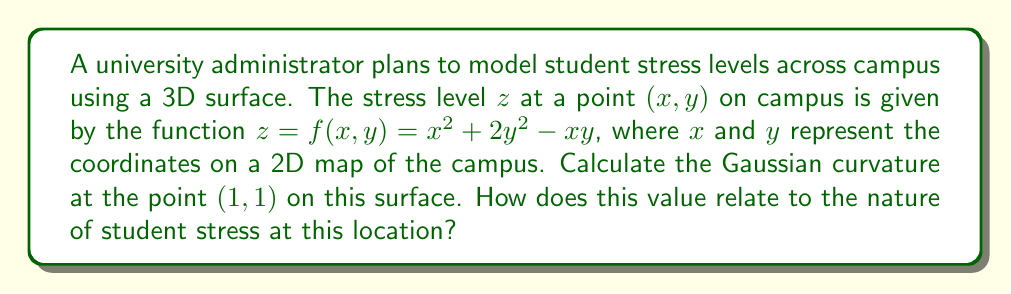Teach me how to tackle this problem. To find the Gaussian curvature, we need to follow these steps:

1) The Gaussian curvature K is given by:
   $$K = \frac{f_{xx}f_{yy} - f_{xy}^2}{(1 + f_x^2 + f_y^2)^2}$$

2) Calculate the partial derivatives:
   $$f_x = 2x - y$$
   $$f_y = 4y - x$$
   $$f_{xx} = 2$$
   $$f_{yy} = 4$$
   $$f_{xy} = -1$$

3) Evaluate these at the point (1,1):
   $$f_x(1,1) = 2(1) - 1 = 1$$
   $$f_y(1,1) = 4(1) - 1 = 3$$
   $$f_{xx}(1,1) = 2$$
   $$f_{yy}(1,1) = 4$$
   $$f_{xy}(1,1) = -1$$

4) Substitute into the Gaussian curvature formula:
   $$K = \frac{(2)(4) - (-1)^2}{(1 + 1^2 + 3^2)^2} = \frac{7}{(11)^2} = \frac{7}{121}$$

5) Interpret the result:
   The positive Gaussian curvature indicates that the surface is dome-shaped at (1,1). This suggests that this location is a local maximum of stress, representing a stress "hotspot" on campus.
Answer: $K = \frac{7}{121}$; positive curvature indicates a local stress maximum. 